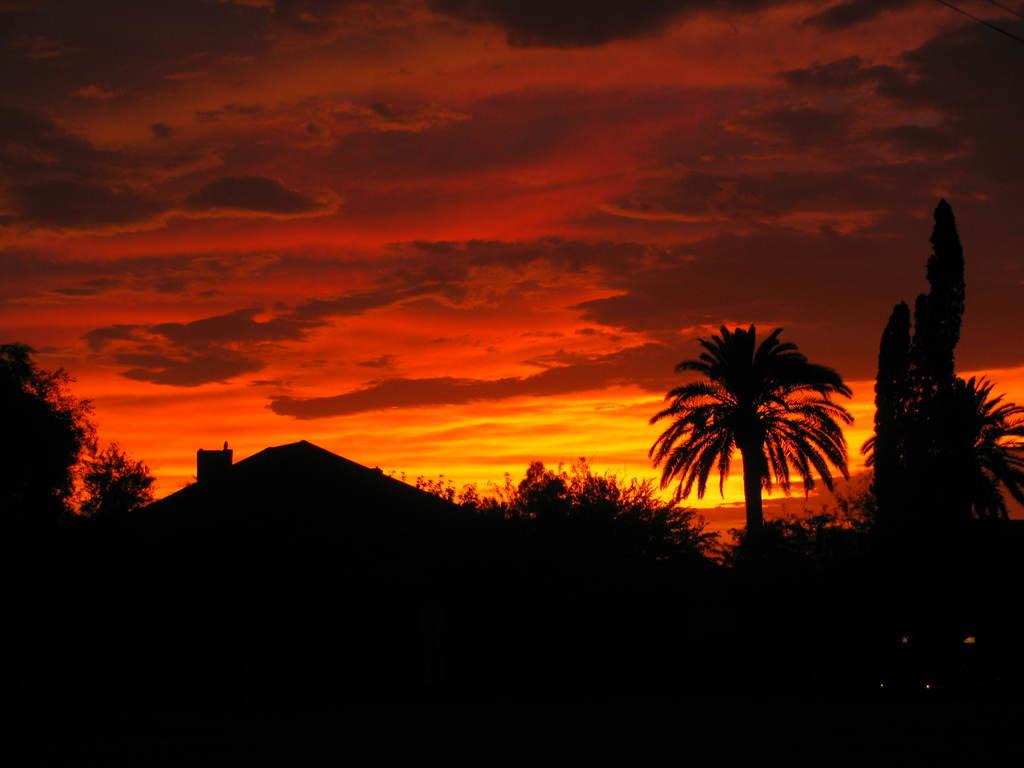What is the overall lighting condition of the image? The image is dark. What type of structures can be seen in the image? There are houses in the image. What other natural elements are present in the image? There are trees in the image. How would you describe the color of the sky in the image? The sky is orange colored in the image. Are there any weather-related features visible in the sky? Yes, clouds are visible in the sky. Can you see a gun being fired in the image? No, there is no gun or any indication of a gun being fired in the image. How many ducks are flying in the orange sky? There are no ducks present in the image; it only features houses, trees, and clouds in the sky. 